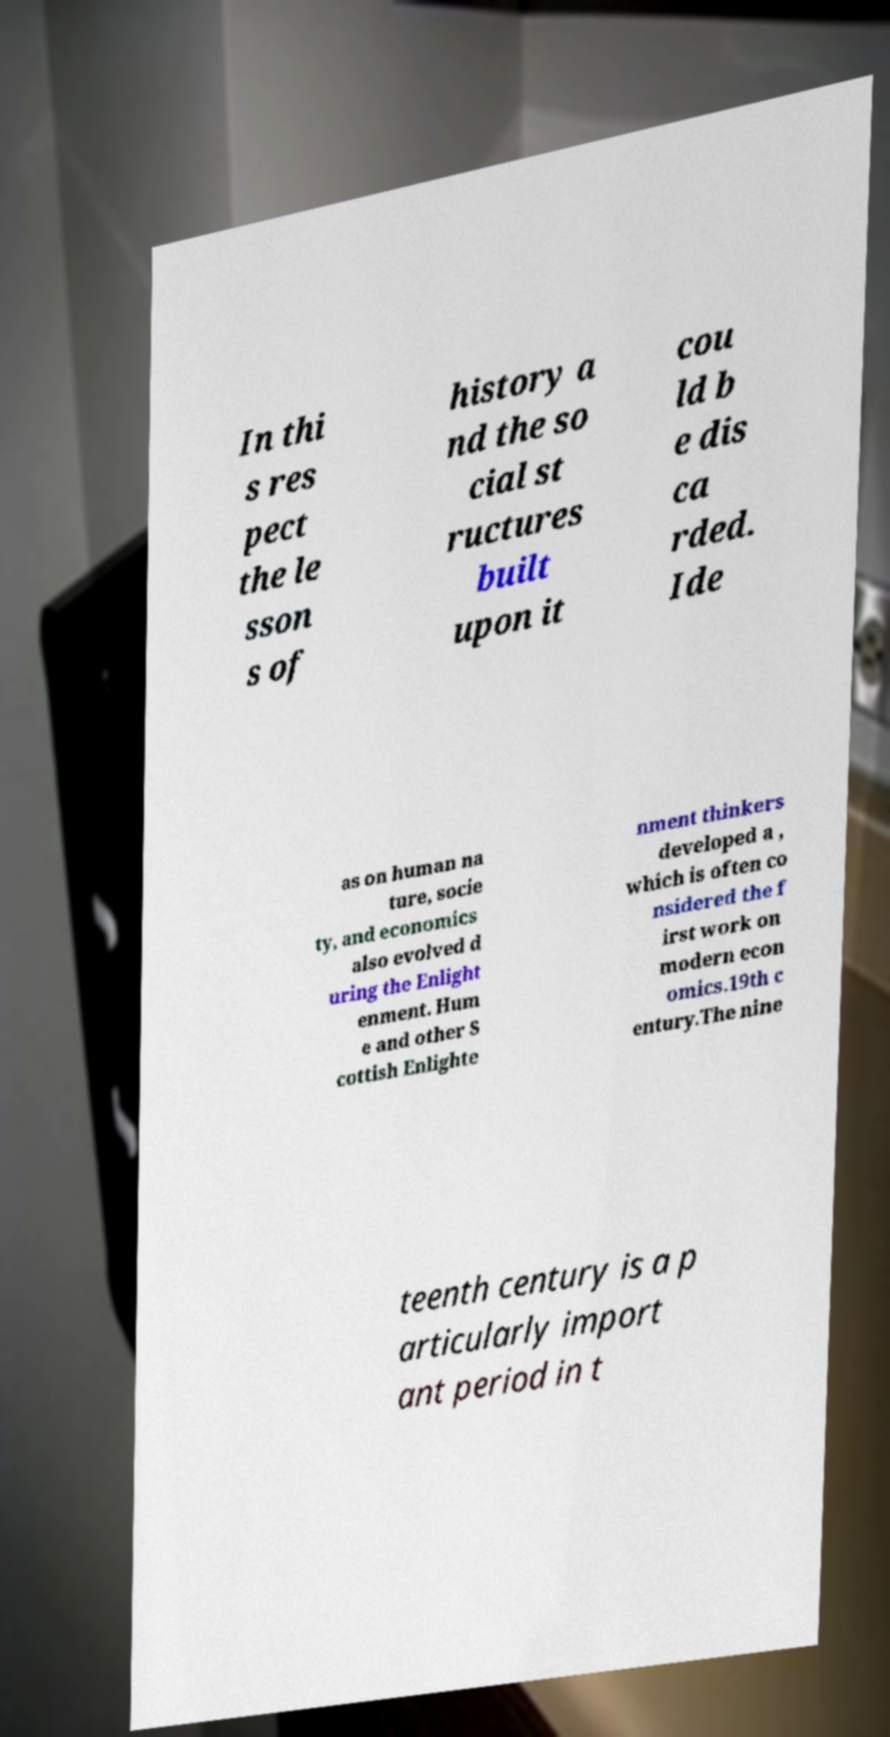There's text embedded in this image that I need extracted. Can you transcribe it verbatim? In thi s res pect the le sson s of history a nd the so cial st ructures built upon it cou ld b e dis ca rded. Ide as on human na ture, socie ty, and economics also evolved d uring the Enlight enment. Hum e and other S cottish Enlighte nment thinkers developed a , which is often co nsidered the f irst work on modern econ omics.19th c entury.The nine teenth century is a p articularly import ant period in t 